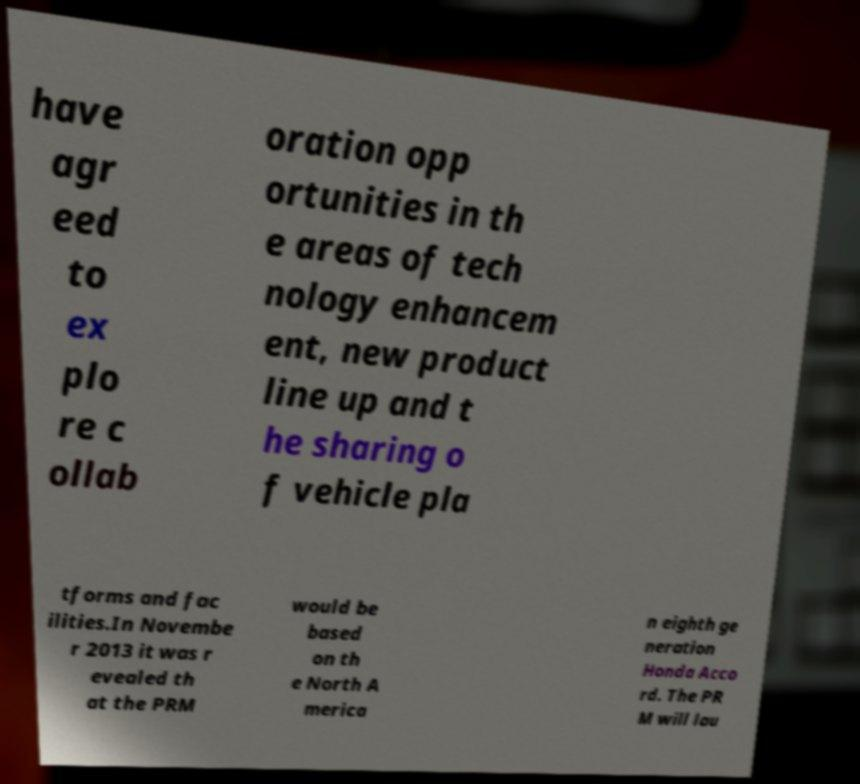For documentation purposes, I need the text within this image transcribed. Could you provide that? have agr eed to ex plo re c ollab oration opp ortunities in th e areas of tech nology enhancem ent, new product line up and t he sharing o f vehicle pla tforms and fac ilities.In Novembe r 2013 it was r evealed th at the PRM would be based on th e North A merica n eighth ge neration Honda Acco rd. The PR M will lau 